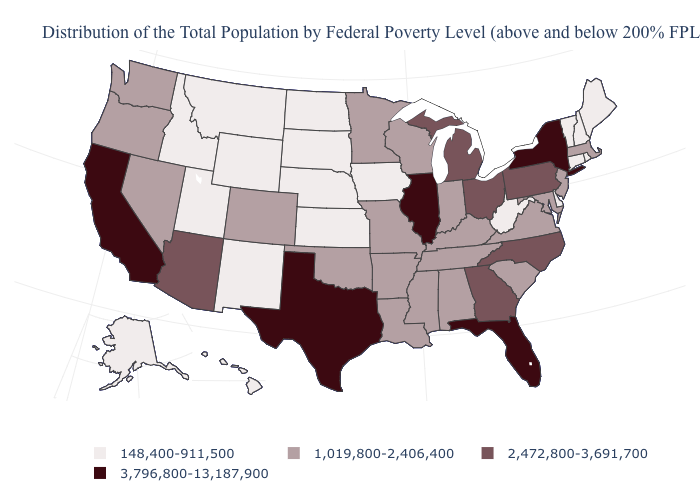Which states have the lowest value in the South?
Concise answer only. Delaware, West Virginia. What is the value of North Carolina?
Short answer required. 2,472,800-3,691,700. Name the states that have a value in the range 3,796,800-13,187,900?
Quick response, please. California, Florida, Illinois, New York, Texas. Among the states that border New York , does Vermont have the highest value?
Concise answer only. No. What is the highest value in states that border New Hampshire?
Give a very brief answer. 1,019,800-2,406,400. Does South Carolina have a higher value than Nebraska?
Write a very short answer. Yes. What is the value of Tennessee?
Short answer required. 1,019,800-2,406,400. How many symbols are there in the legend?
Be succinct. 4. How many symbols are there in the legend?
Short answer required. 4. Which states hav the highest value in the West?
Concise answer only. California. Does Wisconsin have a higher value than Arizona?
Write a very short answer. No. Name the states that have a value in the range 148,400-911,500?
Concise answer only. Alaska, Connecticut, Delaware, Hawaii, Idaho, Iowa, Kansas, Maine, Montana, Nebraska, New Hampshire, New Mexico, North Dakota, Rhode Island, South Dakota, Utah, Vermont, West Virginia, Wyoming. Among the states that border Louisiana , which have the highest value?
Short answer required. Texas. Name the states that have a value in the range 1,019,800-2,406,400?
Write a very short answer. Alabama, Arkansas, Colorado, Indiana, Kentucky, Louisiana, Maryland, Massachusetts, Minnesota, Mississippi, Missouri, Nevada, New Jersey, Oklahoma, Oregon, South Carolina, Tennessee, Virginia, Washington, Wisconsin. 